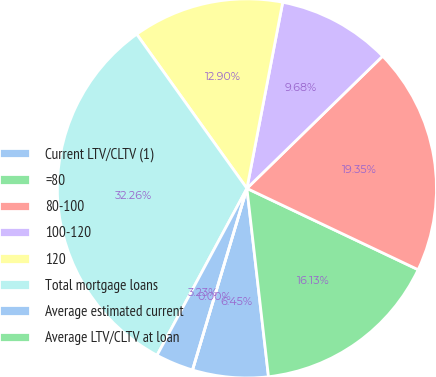Convert chart to OTSL. <chart><loc_0><loc_0><loc_500><loc_500><pie_chart><fcel>Current LTV/CLTV (1)<fcel>=80<fcel>80-100<fcel>100-120<fcel>120<fcel>Total mortgage loans<fcel>Average estimated current<fcel>Average LTV/CLTV at loan<nl><fcel>6.45%<fcel>16.13%<fcel>19.35%<fcel>9.68%<fcel>12.9%<fcel>32.26%<fcel>3.23%<fcel>0.0%<nl></chart> 